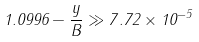<formula> <loc_0><loc_0><loc_500><loc_500>1 . 0 9 9 6 - \frac { y } { B } \gg 7 . 7 2 \times 1 0 ^ { - 5 }</formula> 